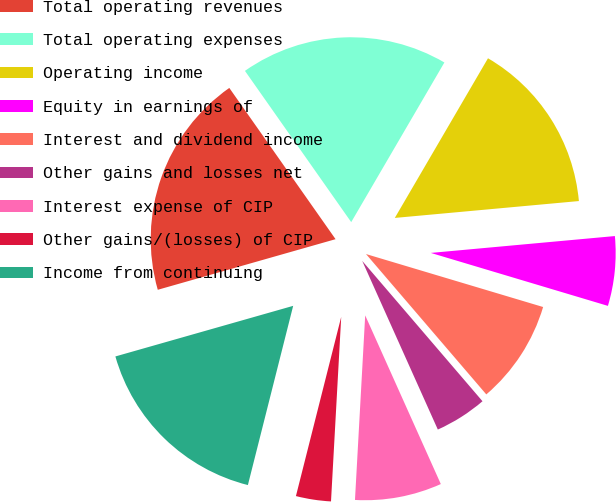<chart> <loc_0><loc_0><loc_500><loc_500><pie_chart><fcel>Total operating revenues<fcel>Total operating expenses<fcel>Operating income<fcel>Equity in earnings of<fcel>Interest and dividend income<fcel>Other gains and losses net<fcel>Interest expense of CIP<fcel>Other gains/(losses) of CIP<fcel>Income from continuing<nl><fcel>19.67%<fcel>18.16%<fcel>15.14%<fcel>6.08%<fcel>9.1%<fcel>4.57%<fcel>7.59%<fcel>3.06%<fcel>16.65%<nl></chart> 